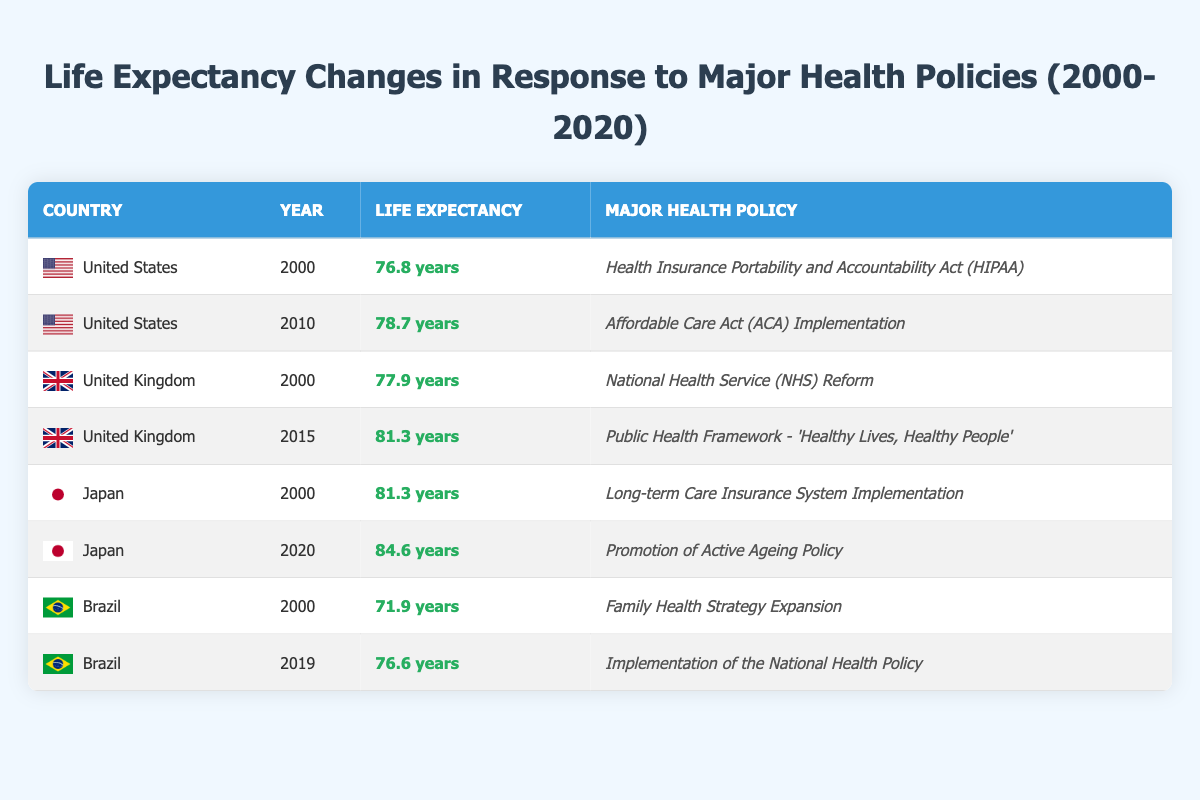What was the life expectancy in the United States in 2000? According to the table, the life expectancy in the United States in 2000 is listed as 76.8 years.
Answer: 76.8 years What is the difference in life expectancy between Japan in 2000 and Japan in 2020? For Japan in 2000, the life expectancy is 81.3 years. In 2020, it is 84.6 years. The difference is calculated as 84.6 - 81.3 = 3.3 years.
Answer: 3.3 years Did the United Kingdom have a life expectancy of over 80 years in 2015? The table indicates that in 2015, the life expectancy in the United Kingdom was 81.3 years, which is indeed over 80 years.
Answer: Yes Which country had the lowest life expectancy recorded in the table, and what was it? By comparing all the entries, Brazil in 2000 shows the lowest life expectancy at 71.9 years, which is lower than all other countries listed.
Answer: Brazil, 71.9 years What was the average life expectancy for the United States in the years available (2000 and 2010)? The life expectancy in the United States for the two years is 76.8 years (2000) and 78.7 years (2010). First, calculate the sum: 76.8 + 78.7 = 155.5. Then, divide by 2 to find the average: 155.5 / 2 = 77.75 years.
Answer: 77.75 years How many major health policies are listed for Japan, and what years do they correspond to? The table lists two major health policies for Japan: one for 2000 (Long-term Care Insurance System Implementation) and another for 2020 (Promotion of Active Ageing Policy), making a total of two policies.
Answer: Two Was there a recorded life expectancy increase in Brazil from 2000 to 2019? In 2000, Brazil's life expectancy was 71.9 years, and in 2019 it was 76.6 years. The difference shows an increase (76.6 - 71.9 = 4.7 years), so there was an increase.
Answer: Yes Which country experienced the highest increase in life expectancy from the year listed? By examining the increases: 
- United States: 78.7 - 76.8 = 1.9 years,
- United Kingdom: 81.3 - 77.9 = 3.4 years,
- Japan: 84.6 - 81.3 = 3.3 years,
- Brazil: 76.6 - 71.9 = 4.7 years. 
Brazil experienced the highest increase with an increase of 4.7 years.
Answer: Brazil What was the life expectancy in Brazil in 2019, and how does it compare to the life expectancy in Brazil in 2000? The life expectancy in Brazil in 2019 was 76.6 years, compared to 71.9 years in 2000. The difference is calculated as 76.6 - 71.9 = 4.7 years, indicating that it increased by 4.7 years.
Answer: 76.6 years, increased by 4.7 years 